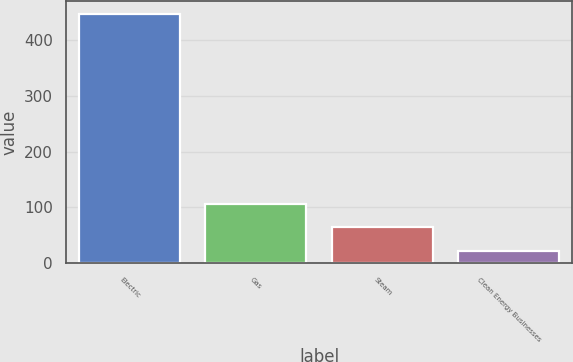Convert chart to OTSL. <chart><loc_0><loc_0><loc_500><loc_500><bar_chart><fcel>Electric<fcel>Gas<fcel>Steam<fcel>Clean Energy Businesses<nl><fcel>447<fcel>107<fcel>64.5<fcel>22<nl></chart> 